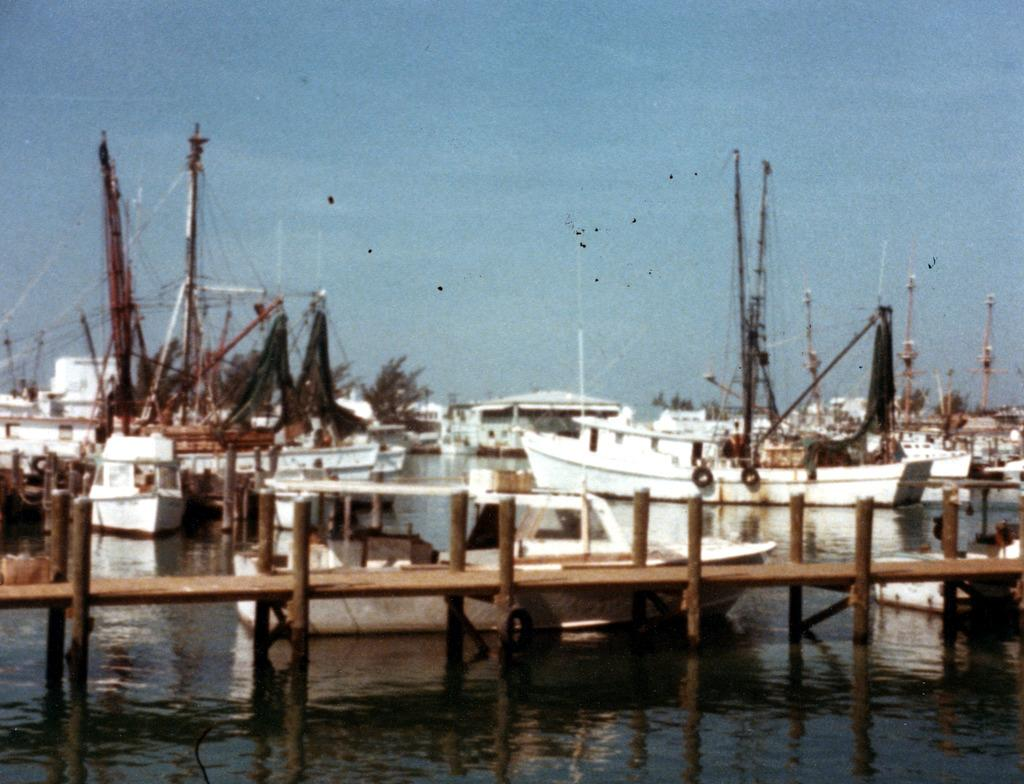What is the main element in the image? There is water in the image. What structure can be seen crossing the water? There is a wooden bridge in the image. What type of vehicles are present in the image? There are boats in the image, and they are white in color. Where are the boats located in relation to the water? The boats are on the surface of the water. What can be seen in the background of the image? There are trees and the sky visible in the background of the image. How many mice can be seen running on the wooden bridge in the image? There are no mice present in the image; it features water, a wooden bridge, boats, trees, and the sky. What type of wrist accessory is visible on the boats in the image? There are no wrist accessories present on the boats in the image. 